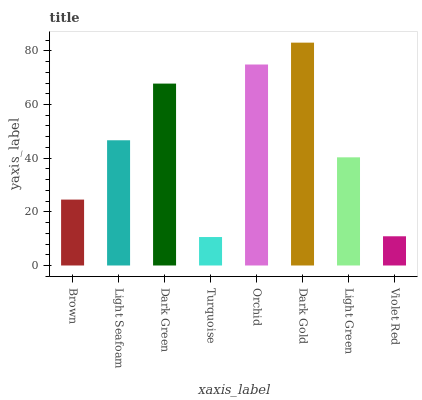Is Turquoise the minimum?
Answer yes or no. Yes. Is Dark Gold the maximum?
Answer yes or no. Yes. Is Light Seafoam the minimum?
Answer yes or no. No. Is Light Seafoam the maximum?
Answer yes or no. No. Is Light Seafoam greater than Brown?
Answer yes or no. Yes. Is Brown less than Light Seafoam?
Answer yes or no. Yes. Is Brown greater than Light Seafoam?
Answer yes or no. No. Is Light Seafoam less than Brown?
Answer yes or no. No. Is Light Seafoam the high median?
Answer yes or no. Yes. Is Light Green the low median?
Answer yes or no. Yes. Is Brown the high median?
Answer yes or no. No. Is Turquoise the low median?
Answer yes or no. No. 